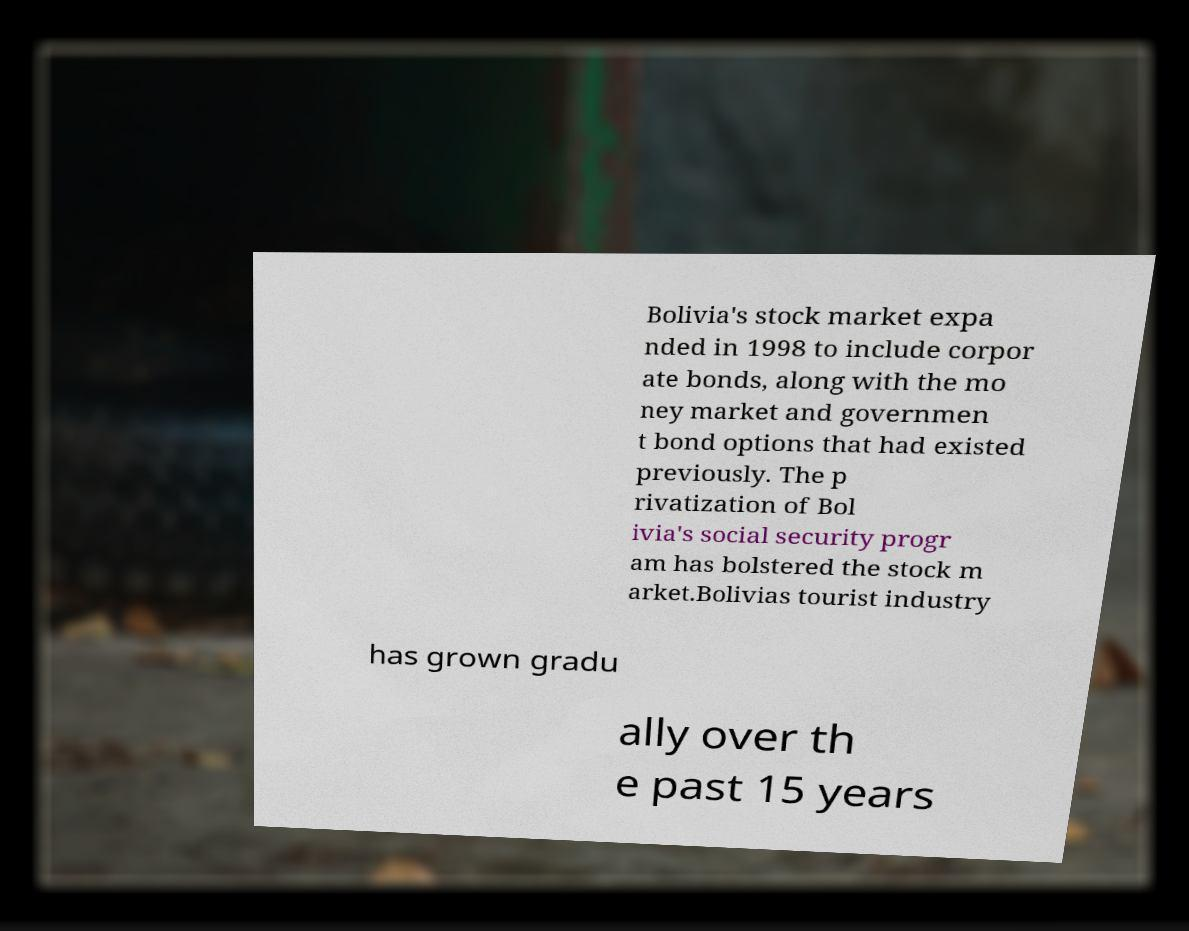Can you accurately transcribe the text from the provided image for me? Bolivia's stock market expa nded in 1998 to include corpor ate bonds, along with the mo ney market and governmen t bond options that had existed previously. The p rivatization of Bol ivia's social security progr am has bolstered the stock m arket.Bolivias tourist industry has grown gradu ally over th e past 15 years 